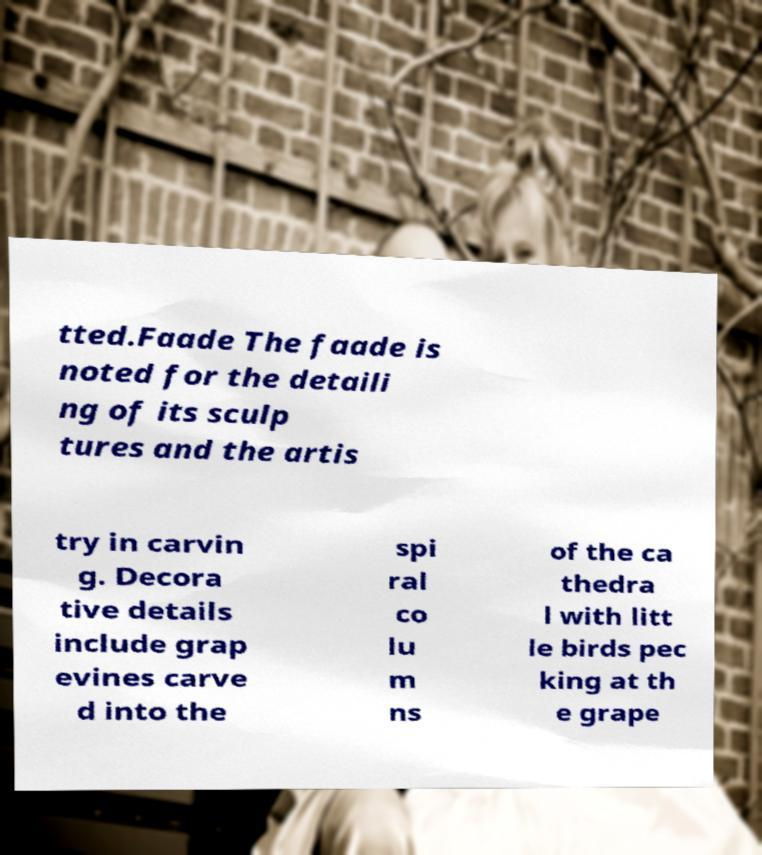For documentation purposes, I need the text within this image transcribed. Could you provide that? tted.Faade The faade is noted for the detaili ng of its sculp tures and the artis try in carvin g. Decora tive details include grap evines carve d into the spi ral co lu m ns of the ca thedra l with litt le birds pec king at th e grape 